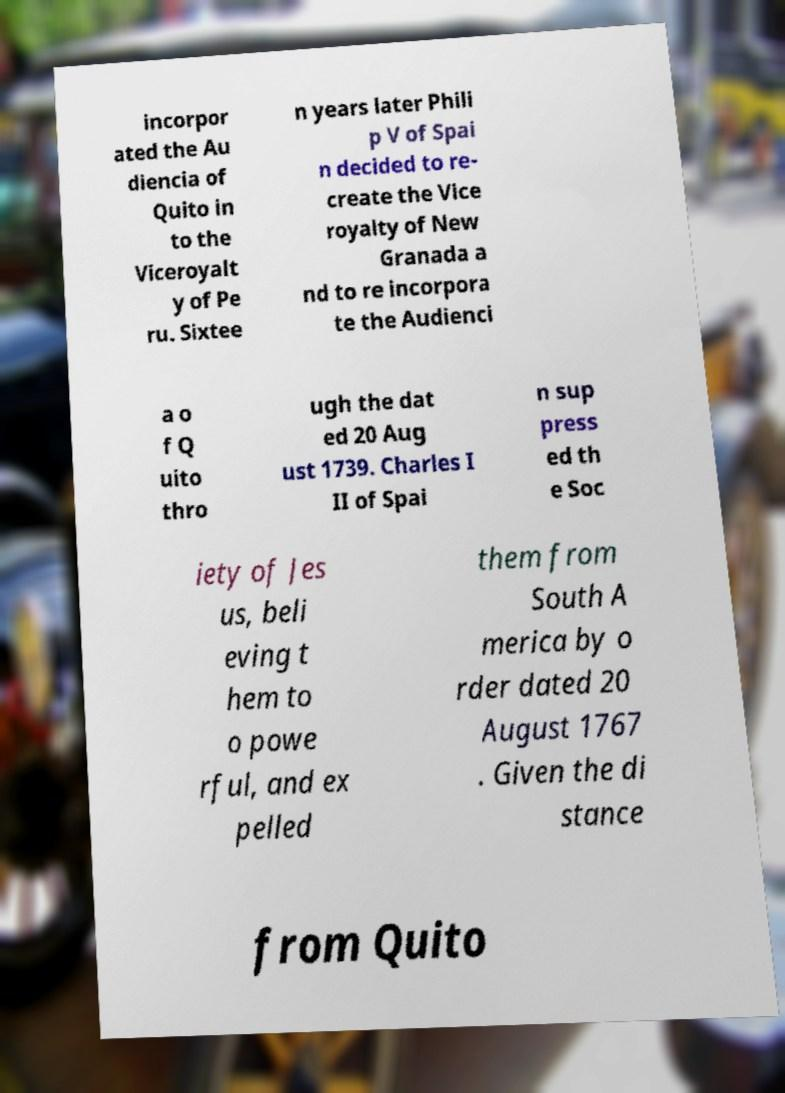Could you extract and type out the text from this image? incorpor ated the Au diencia of Quito in to the Viceroyalt y of Pe ru. Sixtee n years later Phili p V of Spai n decided to re- create the Vice royalty of New Granada a nd to re incorpora te the Audienci a o f Q uito thro ugh the dat ed 20 Aug ust 1739. Charles I II of Spai n sup press ed th e Soc iety of Jes us, beli eving t hem to o powe rful, and ex pelled them from South A merica by o rder dated 20 August 1767 . Given the di stance from Quito 